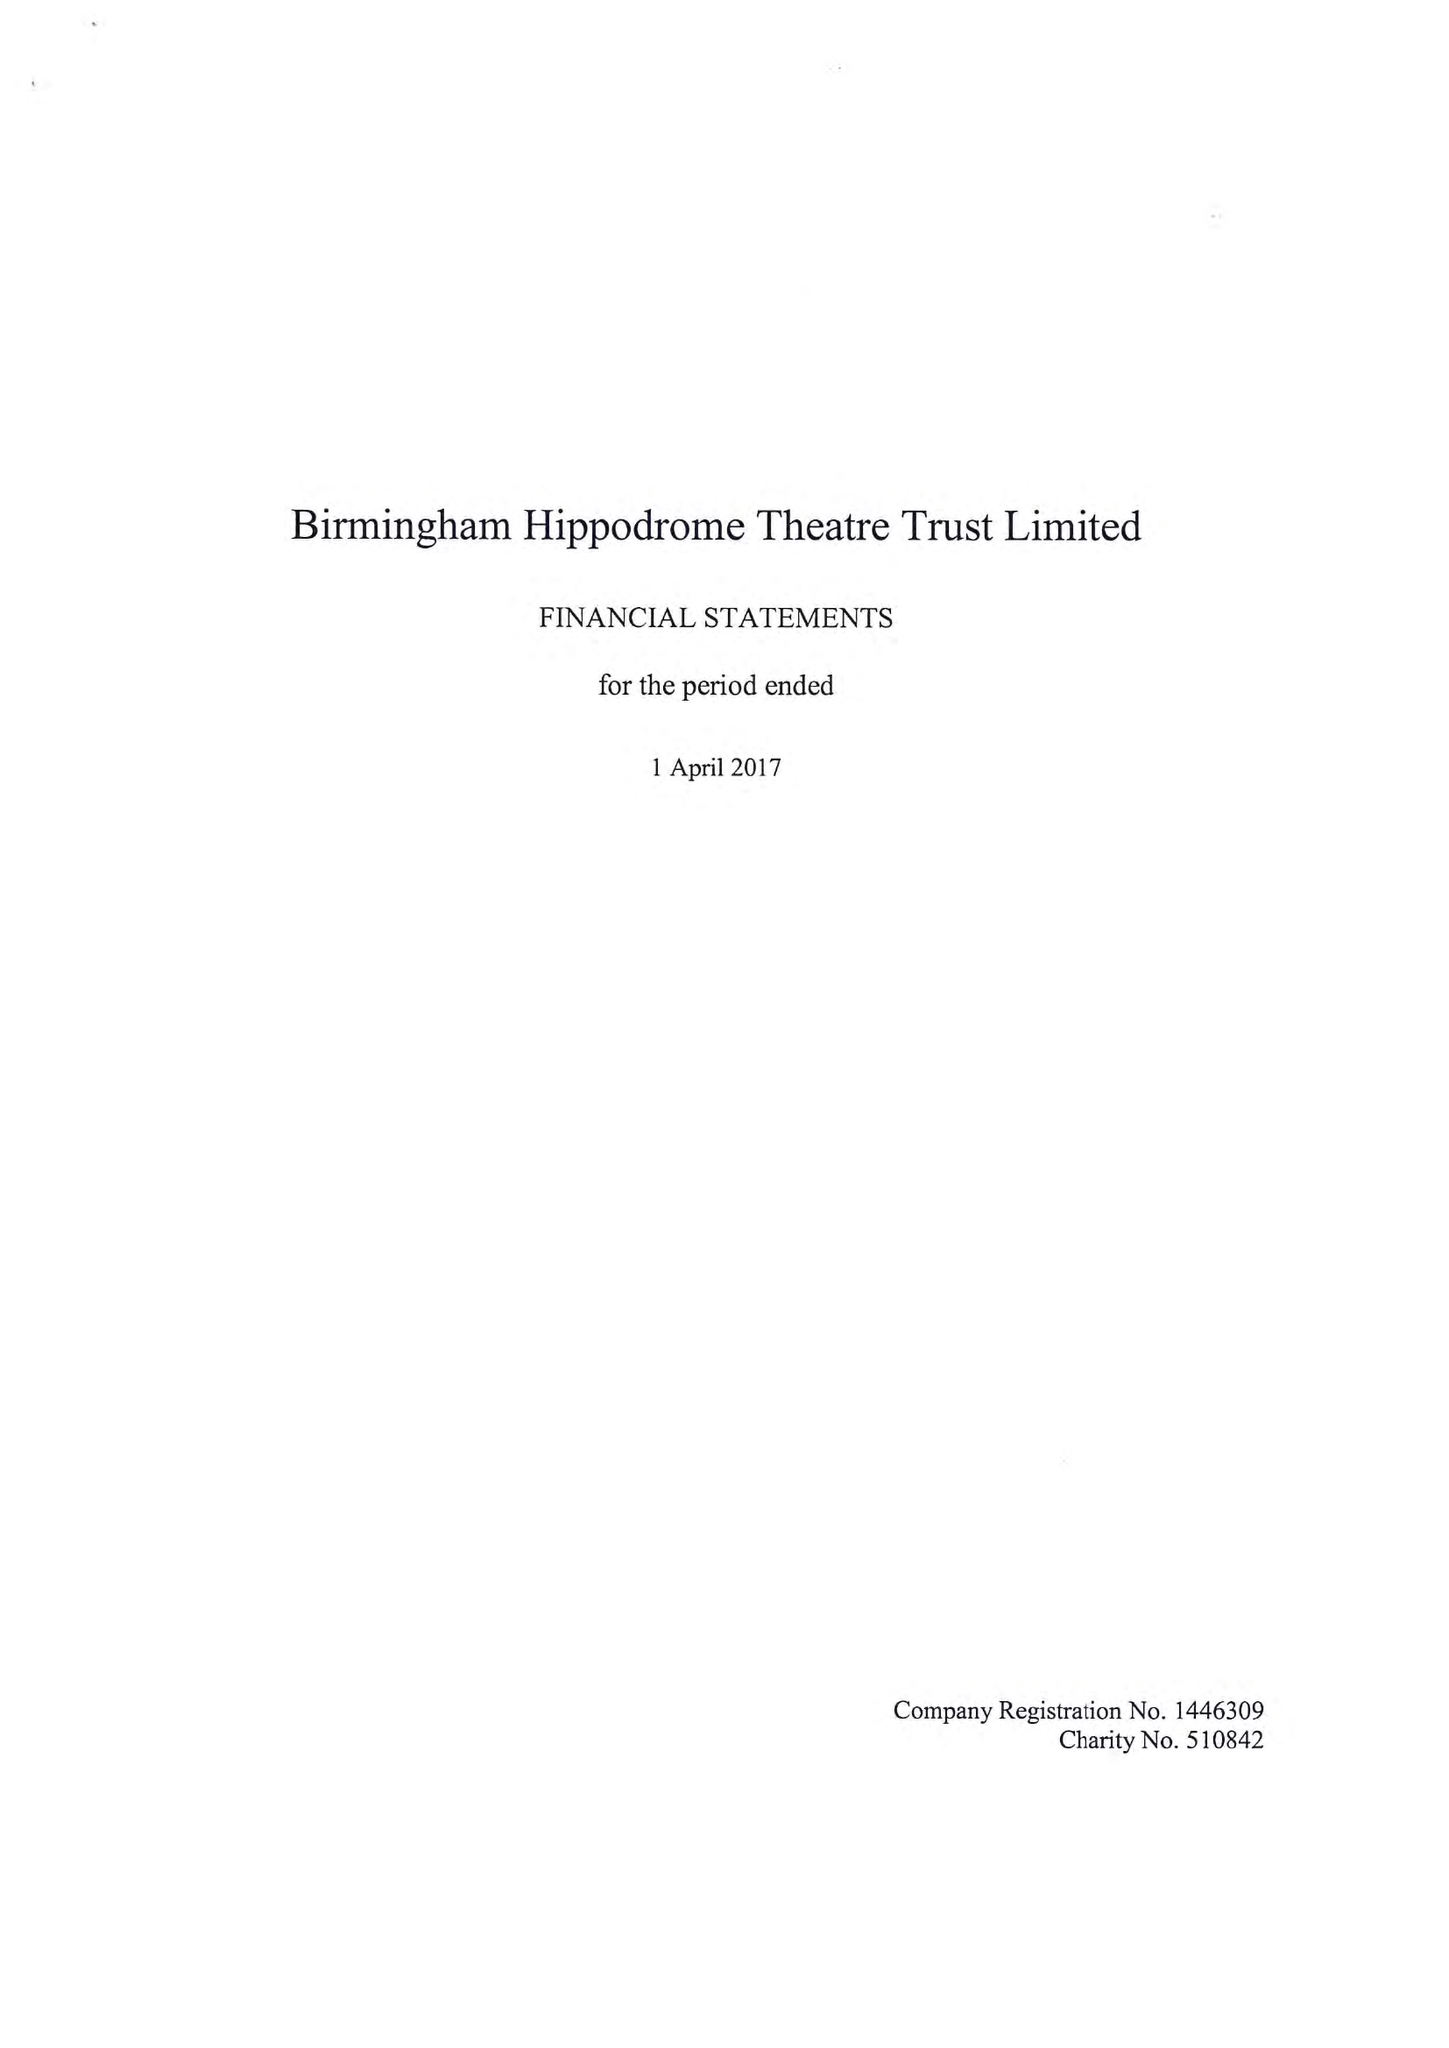What is the value for the address__post_town?
Answer the question using a single word or phrase. BIRMINGHAM 